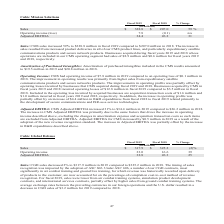According to Cubic's financial document, What is the percentage increase in CGD operating income in 2019? Based on the financial document, the answer is 39%. Also, What resulted in the improvement in operating profits? The document shows two values: primarily due to the results of cost reduction efforts, including headcount reductions designed to optimize our cost position, and reduced R&D expenditures and increased sales of ground combat training system sales. Also, For which fiscal year(s) is the amount of amortization of purchased intangibles included in the CGD results recorded? The document shows two values: 2019 and 2018. From the document: "Fiscal 2019 Fiscal 2018 % Change (in millions) Fiscal 2019 Fiscal 2018 % Change (in millions)..." Additionally, In which year was the amount of amortization of purchased intangibles included in the CGD results larger? According to the financial document, 2018. The relevant text states: "Fiscal 2019 Fiscal 2018 % Change (in millions)..." Also, can you calculate: What is the change in the amount of sales from 2018 to 2019? Based on the calculation: 317.9-325.2, the result is -7.3 (in millions). This is based on the information: "Sales $ 317.9 $ 325.2 (2)% Operating income 23.0 16.6 39 Sales $ 317.9 $ 325.2 (2)% Operating income 23.0 16.6 39..." The key data points involved are: 317.9, 325.2. Also, can you calculate: What is the average amount of adjusted EBITDA in 2018 and 2019? To answer this question, I need to perform calculations using the financial data. The calculation is: (32.8+26.3)/2, which equals 29.55 (in millions). This is based on the information: "Adjusted EBITDA 32.8 26.3 25 Sales: CGD sales decreased 2% to $317.9 million in 2019 compared to $325.2 million in 2018. The Adjusted EBITDA 32.8 26.3 25 Sales: CGD sales decreased 2% to $317.9 millio..." The key data points involved are: 26.3, 32.8. 